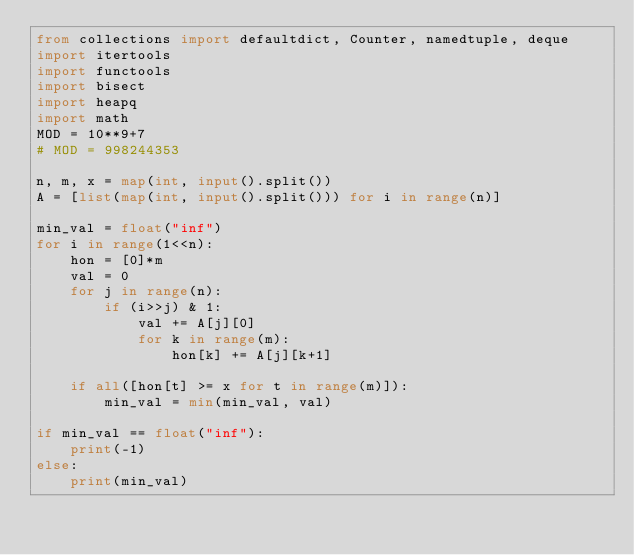Convert code to text. <code><loc_0><loc_0><loc_500><loc_500><_Python_>from collections import defaultdict, Counter, namedtuple, deque
import itertools
import functools
import bisect
import heapq
import math
MOD = 10**9+7
# MOD = 998244353

n, m, x = map(int, input().split())
A = [list(map(int, input().split())) for i in range(n)]

min_val = float("inf")
for i in range(1<<n):
    hon = [0]*m
    val = 0
    for j in range(n):
        if (i>>j) & 1:
            val += A[j][0]
            for k in range(m):
                hon[k] += A[j][k+1]

    if all([hon[t] >= x for t in range(m)]):
        min_val = min(min_val, val)

if min_val == float("inf"):
    print(-1)
else:
    print(min_val)
</code> 